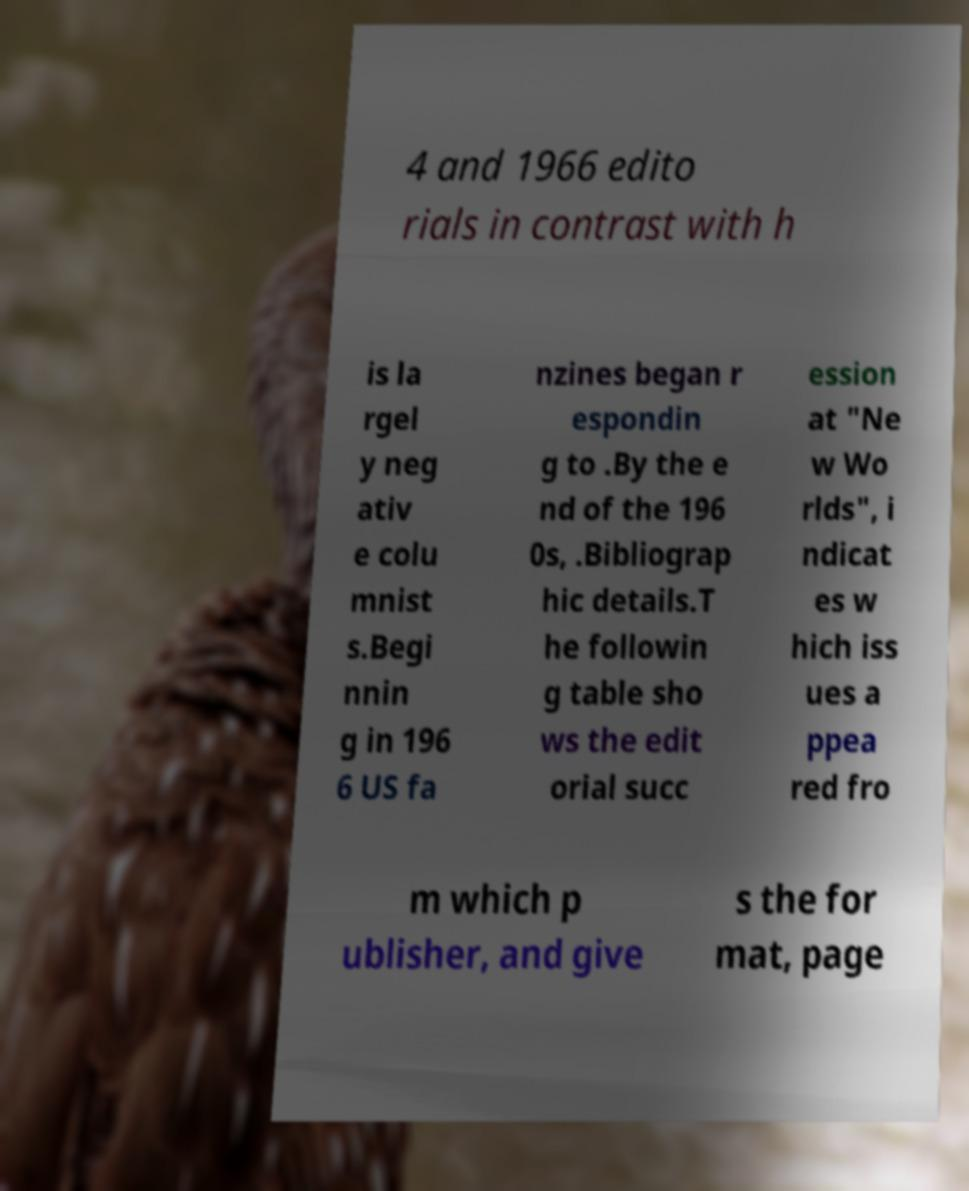There's text embedded in this image that I need extracted. Can you transcribe it verbatim? 4 and 1966 edito rials in contrast with h is la rgel y neg ativ e colu mnist s.Begi nnin g in 196 6 US fa nzines began r espondin g to .By the e nd of the 196 0s, .Bibliograp hic details.T he followin g table sho ws the edit orial succ ession at "Ne w Wo rlds", i ndicat es w hich iss ues a ppea red fro m which p ublisher, and give s the for mat, page 